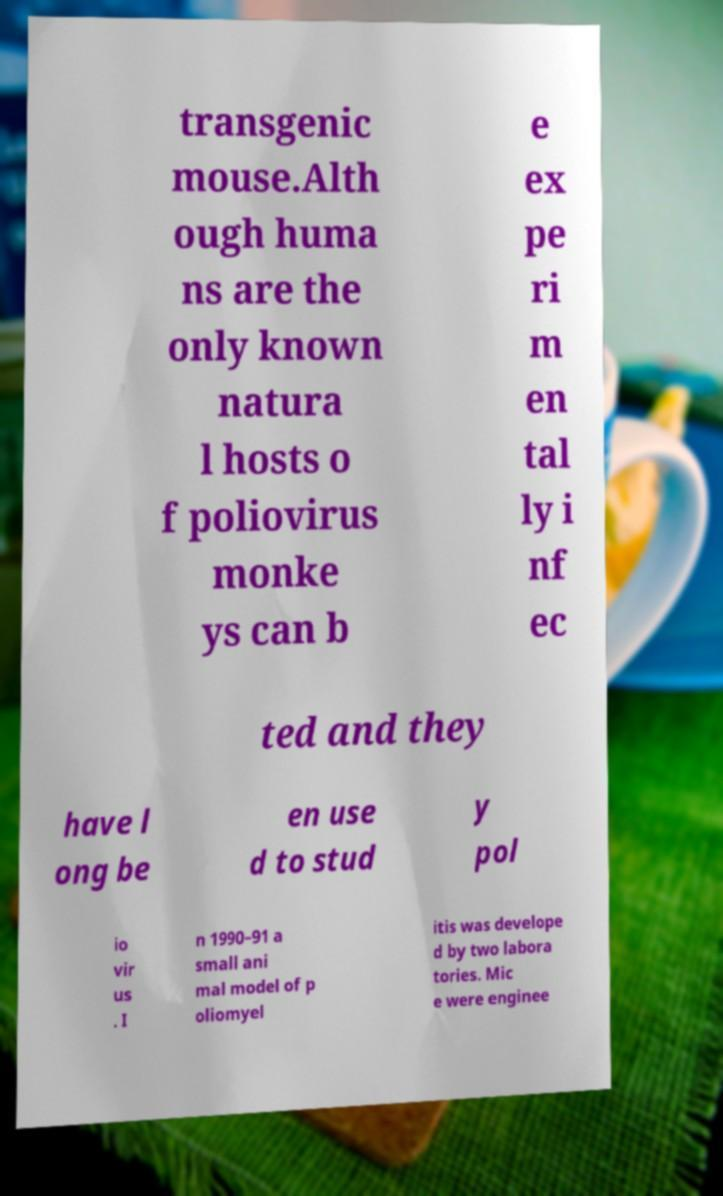Can you accurately transcribe the text from the provided image for me? transgenic mouse.Alth ough huma ns are the only known natura l hosts o f poliovirus monke ys can b e ex pe ri m en tal ly i nf ec ted and they have l ong be en use d to stud y pol io vir us . I n 1990–91 a small ani mal model of p oliomyel itis was develope d by two labora tories. Mic e were enginee 